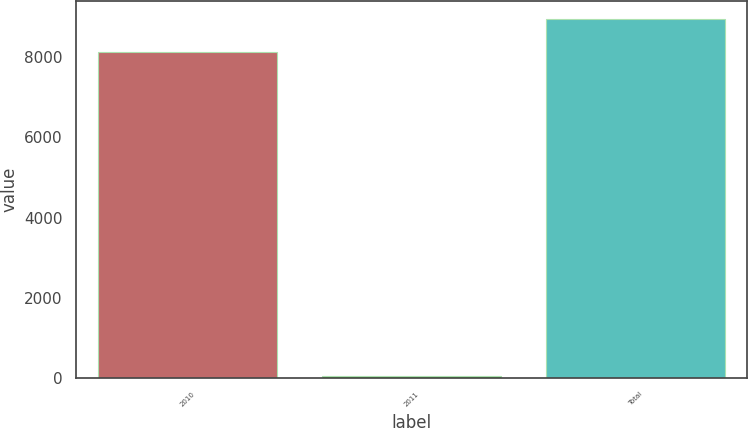Convert chart. <chart><loc_0><loc_0><loc_500><loc_500><bar_chart><fcel>2010<fcel>2011<fcel>Total<nl><fcel>8132<fcel>43<fcel>8945.2<nl></chart> 